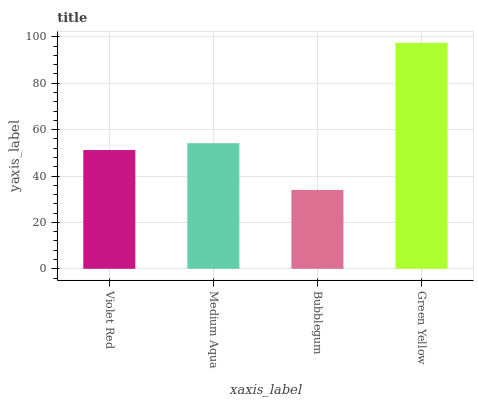Is Bubblegum the minimum?
Answer yes or no. Yes. Is Green Yellow the maximum?
Answer yes or no. Yes. Is Medium Aqua the minimum?
Answer yes or no. No. Is Medium Aqua the maximum?
Answer yes or no. No. Is Medium Aqua greater than Violet Red?
Answer yes or no. Yes. Is Violet Red less than Medium Aqua?
Answer yes or no. Yes. Is Violet Red greater than Medium Aqua?
Answer yes or no. No. Is Medium Aqua less than Violet Red?
Answer yes or no. No. Is Medium Aqua the high median?
Answer yes or no. Yes. Is Violet Red the low median?
Answer yes or no. Yes. Is Green Yellow the high median?
Answer yes or no. No. Is Bubblegum the low median?
Answer yes or no. No. 